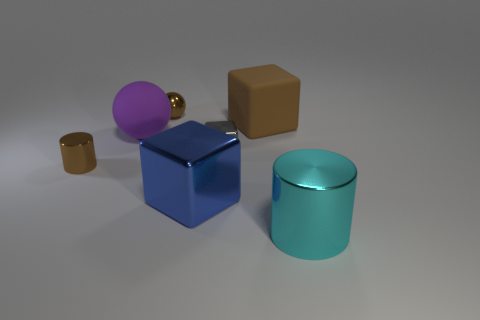Add 3 big metal things. How many objects exist? 10 Subtract all cylinders. How many objects are left? 5 Add 3 small gray shiny blocks. How many small gray shiny blocks are left? 4 Add 5 cubes. How many cubes exist? 8 Subtract 1 brown blocks. How many objects are left? 6 Subtract all red shiny cylinders. Subtract all tiny metallic things. How many objects are left? 4 